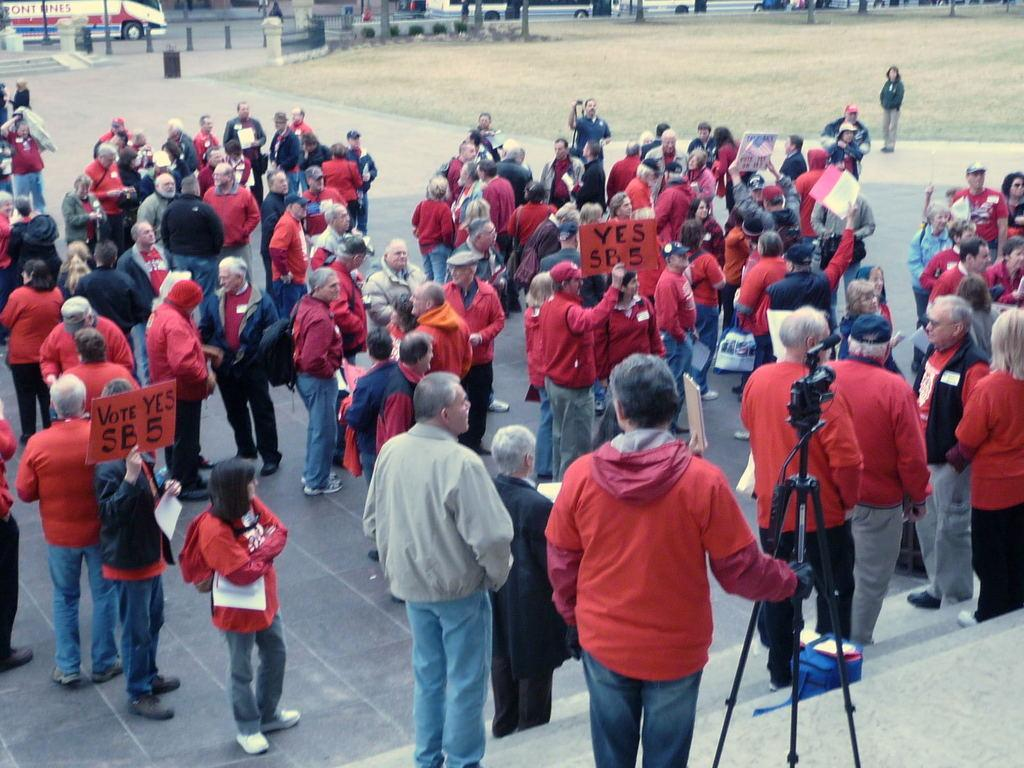What can be seen in the image? There are people standing in the image. What else is visible in the background of the image? There are vehicles on the road in the background of the image. What is the surface that the people and vehicles are standing or moving on? The ground is visible at the bottom of the image. What type of rat can be seen in the image? There is no rat present in the image. 